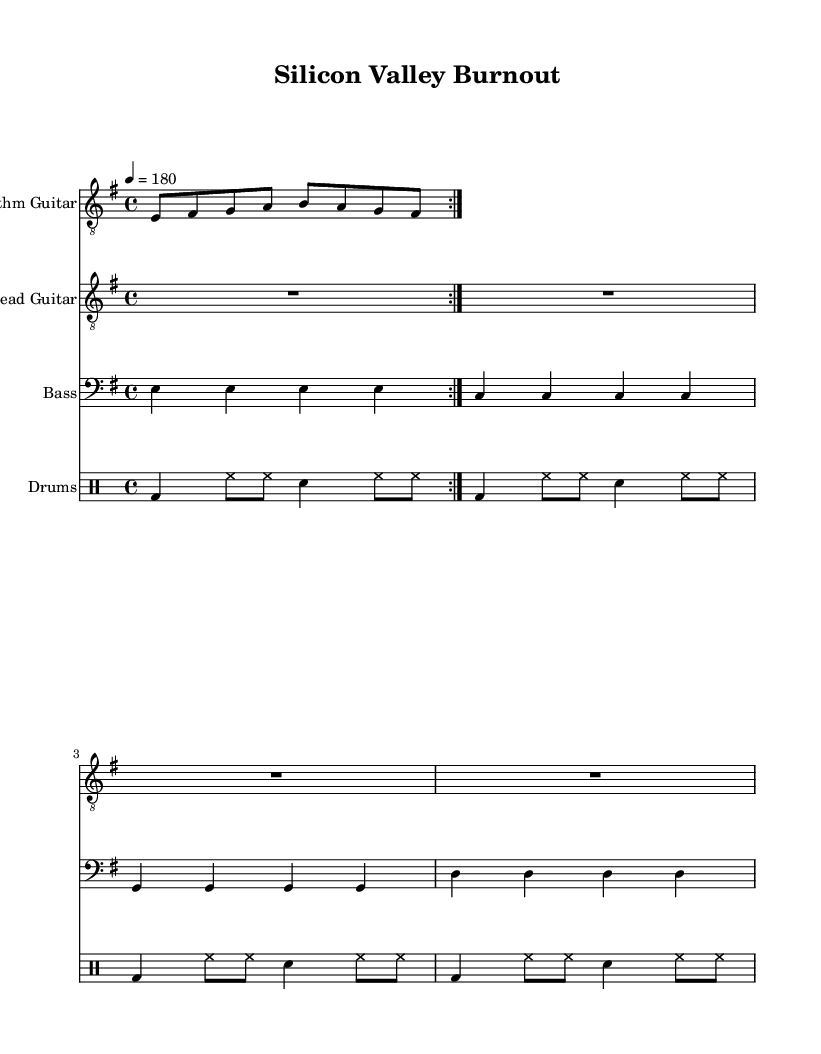What is the key signature of this music? The key signature has one sharp, which indicates that it is in E minor.
Answer: E minor What is the time signature of this music? The time signature is indicated at the beginning as 4/4, showing four beats per measure.
Answer: 4/4 What is the tempo marking for this piece? The tempo marking is 4 equals 180, indicating a fast speed of 180 beats per minute.
Answer: 180 How many measures are in the rhythm guitar part? The rhythm guitar part has a repeat sign indicating that it plays through two measures before repeating, totaling 4 measures.
Answer: 4 measures What type of musical form is indicated for the rhythm guitar? The rhythm guitar uses a repeated volta form, showing that it has sections that are meant to be played more than once.
Answer: Volta What is the primary instrument featured as the lead instrument? The lead part is specifically labeled "Lead Guitar," indicating its primary role in the piece.
Answer: Lead Guitar What is the relationship between the bass and drums in this piece? Both the bass and drums follow a consistent rhythmic pattern throughout the music, supporting the overall thrash metal sound.
Answer: Consistent pattern 